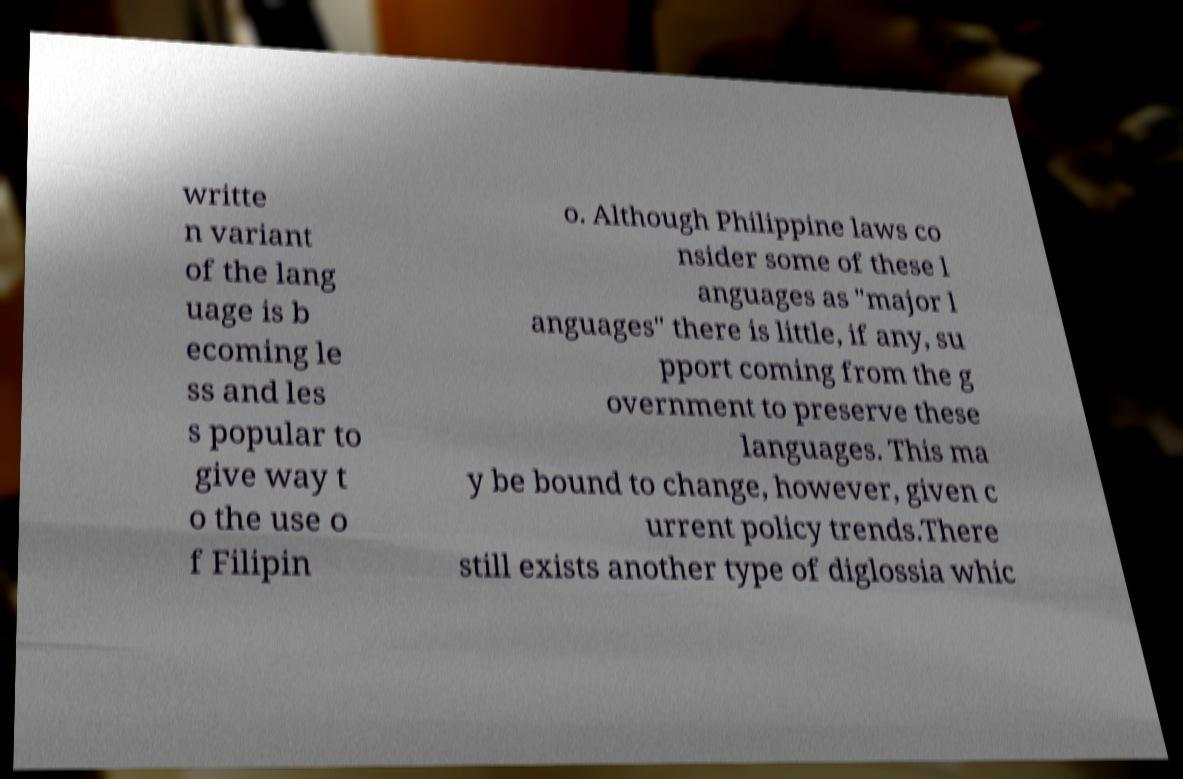Please read and relay the text visible in this image. What does it say? writte n variant of the lang uage is b ecoming le ss and les s popular to give way t o the use o f Filipin o. Although Philippine laws co nsider some of these l anguages as "major l anguages" there is little, if any, su pport coming from the g overnment to preserve these languages. This ma y be bound to change, however, given c urrent policy trends.There still exists another type of diglossia whic 